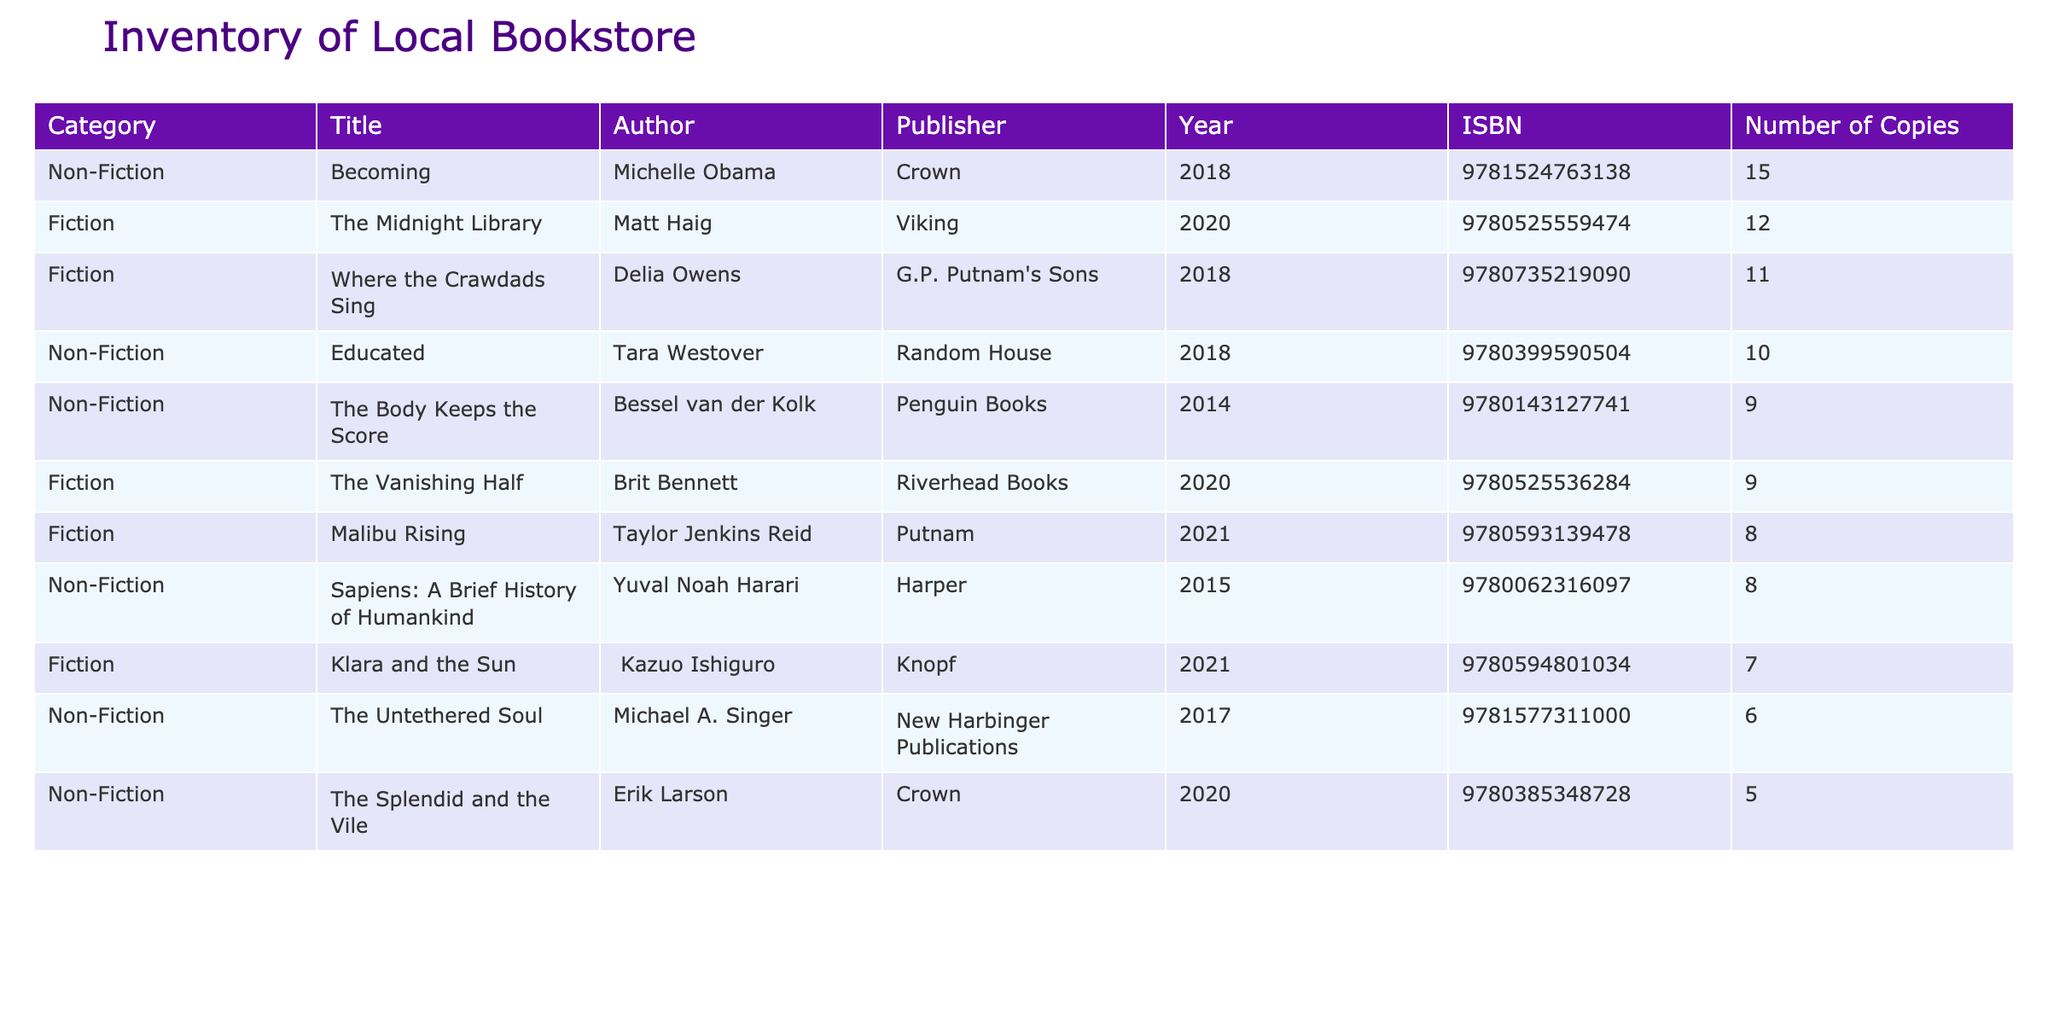What is the title with the highest number of copies? Looking at the "Number of Copies" column, "Becoming" by Michelle Obama has the highest count with 15 copies.
Answer: Becoming How many non-fiction titles are listed in the inventory? There are 5 titles listed under the Non-Fiction category: "Educated," "The Body Keeps the Score," "Becoming," "The Splendid and the Vile," and "The Untethered Soul."
Answer: 5 Which author has written the most copies available in the store? By checking the "Number of Copies" per author, Michelle Obama has the most copies available at 15.
Answer: Michelle Obama What is the total number of copies for all fiction titles? The total number of copies for fiction titles can be calculated by summing the numbers: 12 (The Midnight Library) + 8 (Malibu Rising) + 7 (Klara and the Sun) + 11 (Where the Crawdads Sing) + 9 (The Vanishing Half) = 47 copies in total.
Answer: 47 Is the average number of copies for non-fiction titles greater than 10? The total copies of non-fiction titles are 10 + 9 + 15 + 5 + 6 = 45, and there are 5 titles, so the average is 45/5 = 9. Since 9 is not greater than 10, the answer is no.
Answer: No Which category has more titles listed: fiction or non-fiction? There are a total of 5 titles listed in Fiction and 5 in Non-Fiction. Therefore, both categories have an equal number of titles.
Answer: Equal What is the difference in the number of copies between the best-selling fiction and non-fiction title? "Becoming" has 15 copies while "The Midnight Library" has 12, so the difference is 15 - 12 = 3 copies.
Answer: 3 Are there any non-fiction titles with more than 10 copies? "Becoming" with 15 copies and "Educated" with 10 copies both have more than 10. Therefore, the answer is yes.
Answer: Yes 